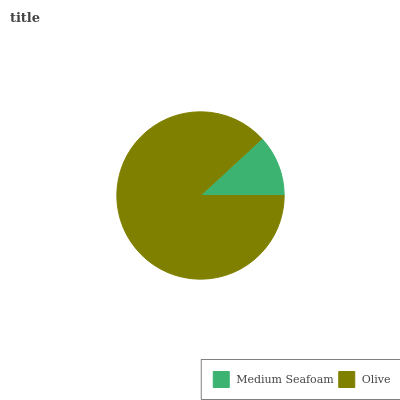Is Medium Seafoam the minimum?
Answer yes or no. Yes. Is Olive the maximum?
Answer yes or no. Yes. Is Olive the minimum?
Answer yes or no. No. Is Olive greater than Medium Seafoam?
Answer yes or no. Yes. Is Medium Seafoam less than Olive?
Answer yes or no. Yes. Is Medium Seafoam greater than Olive?
Answer yes or no. No. Is Olive less than Medium Seafoam?
Answer yes or no. No. Is Olive the high median?
Answer yes or no. Yes. Is Medium Seafoam the low median?
Answer yes or no. Yes. Is Medium Seafoam the high median?
Answer yes or no. No. Is Olive the low median?
Answer yes or no. No. 